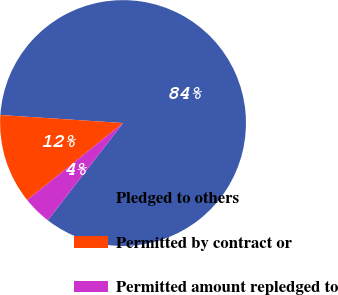<chart> <loc_0><loc_0><loc_500><loc_500><pie_chart><fcel>Pledged to others<fcel>Permitted by contract or<fcel>Permitted amount repledged to<nl><fcel>84.44%<fcel>11.81%<fcel>3.75%<nl></chart> 